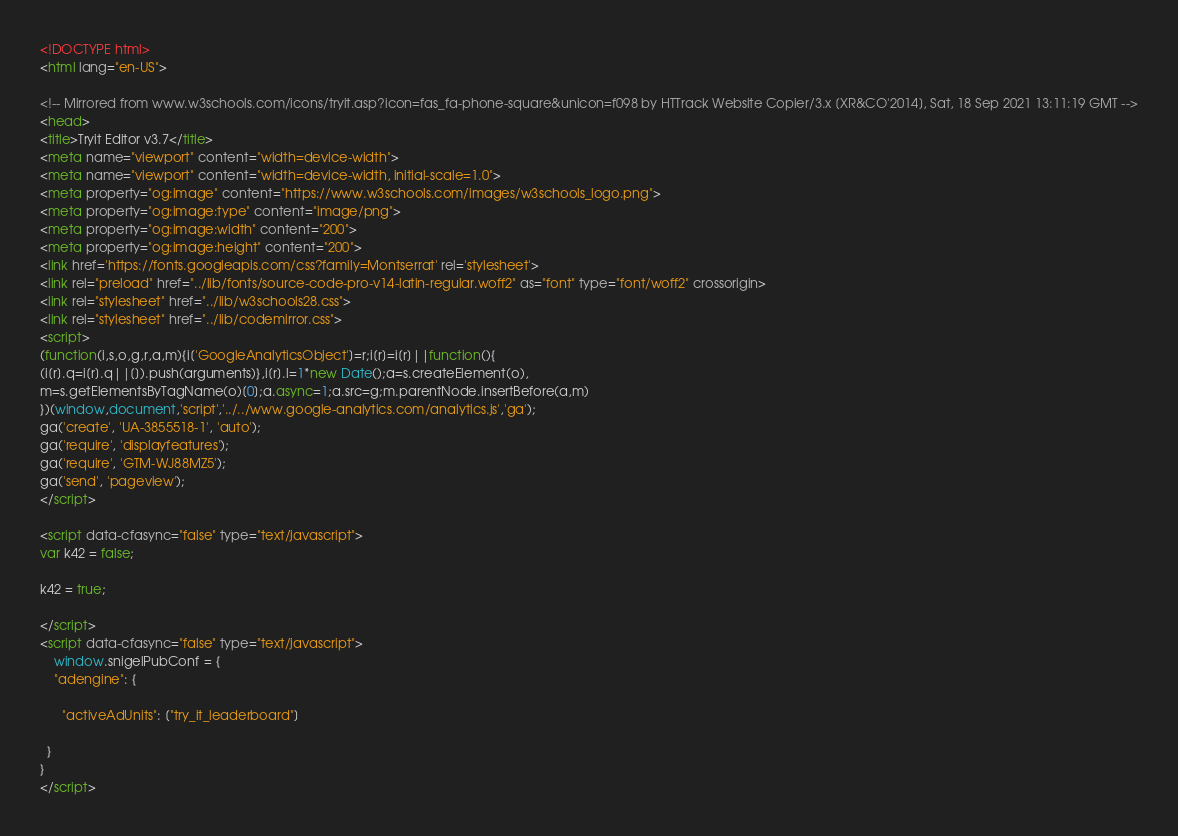Convert code to text. <code><loc_0><loc_0><loc_500><loc_500><_HTML_>
<!DOCTYPE html>
<html lang="en-US">

<!-- Mirrored from www.w3schools.com/icons/tryit.asp?icon=fas_fa-phone-square&unicon=f098 by HTTrack Website Copier/3.x [XR&CO'2014], Sat, 18 Sep 2021 13:11:19 GMT -->
<head>
<title>Tryit Editor v3.7</title>
<meta name="viewport" content="width=device-width">
<meta name="viewport" content="width=device-width, initial-scale=1.0">
<meta property="og:image" content="https://www.w3schools.com/images/w3schools_logo.png">
<meta property="og:image:type" content="image/png">
<meta property="og:image:width" content="200">
<meta property="og:image:height" content="200">
<link href='https://fonts.googleapis.com/css?family=Montserrat' rel='stylesheet'>
<link rel="preload" href="../lib/fonts/source-code-pro-v14-latin-regular.woff2" as="font" type="font/woff2" crossorigin>
<link rel="stylesheet" href="../lib/w3schools28.css">
<link rel="stylesheet" href="../lib/codemirror.css">
<script>
(function(i,s,o,g,r,a,m){i['GoogleAnalyticsObject']=r;i[r]=i[r]||function(){
(i[r].q=i[r].q||[]).push(arguments)},i[r].l=1*new Date();a=s.createElement(o),
m=s.getElementsByTagName(o)[0];a.async=1;a.src=g;m.parentNode.insertBefore(a,m)
})(window,document,'script','../../www.google-analytics.com/analytics.js','ga');
ga('create', 'UA-3855518-1', 'auto');
ga('require', 'displayfeatures');
ga('require', 'GTM-WJ88MZ5');
ga('send', 'pageview');
</script>

<script data-cfasync="false" type="text/javascript">
var k42 = false;

k42 = true;

</script>
<script data-cfasync="false" type="text/javascript">
    window.snigelPubConf = {
    "adengine": {

      "activeAdUnits": ["try_it_leaderboard"]

  }
}
</script></code> 